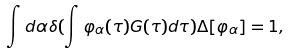<formula> <loc_0><loc_0><loc_500><loc_500>\int d \alpha \delta ( \int \varphi _ { \alpha } ( \tau ) G ( \tau ) d \tau ) \Delta [ \varphi _ { \alpha } ] = 1 ,</formula> 